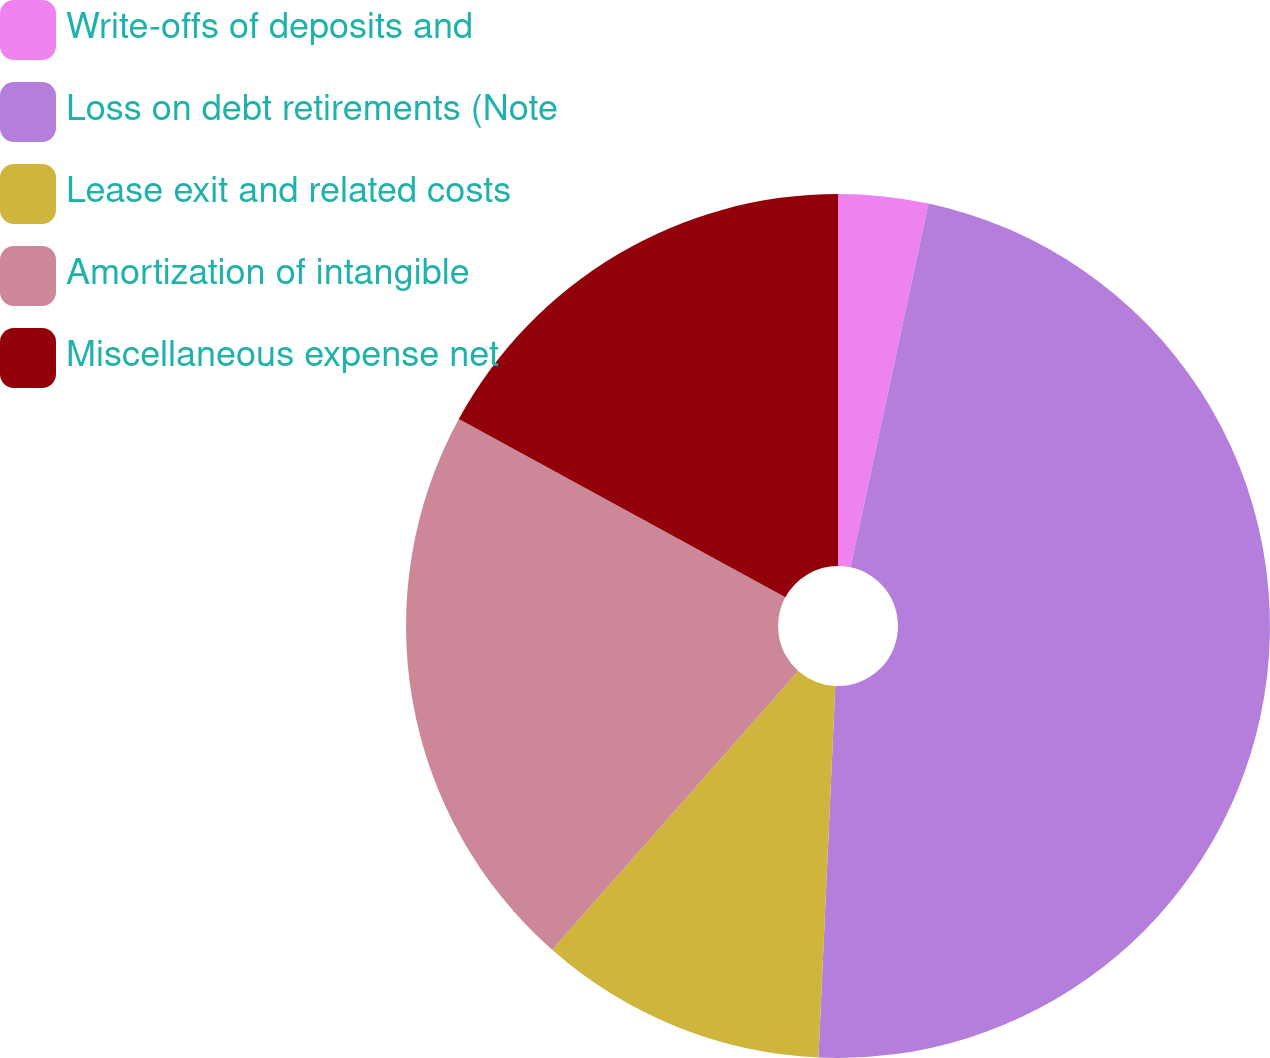Convert chart to OTSL. <chart><loc_0><loc_0><loc_500><loc_500><pie_chart><fcel>Write-offs of deposits and<fcel>Loss on debt retirements (Note<fcel>Lease exit and related costs<fcel>Amortization of intangible<fcel>Miscellaneous expense net<nl><fcel>3.36%<fcel>47.36%<fcel>10.79%<fcel>21.44%<fcel>17.05%<nl></chart> 